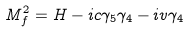<formula> <loc_0><loc_0><loc_500><loc_500>M _ { f } ^ { 2 } = H - i c \gamma _ { 5 } \gamma _ { 4 } - i v \gamma _ { 4 }</formula> 